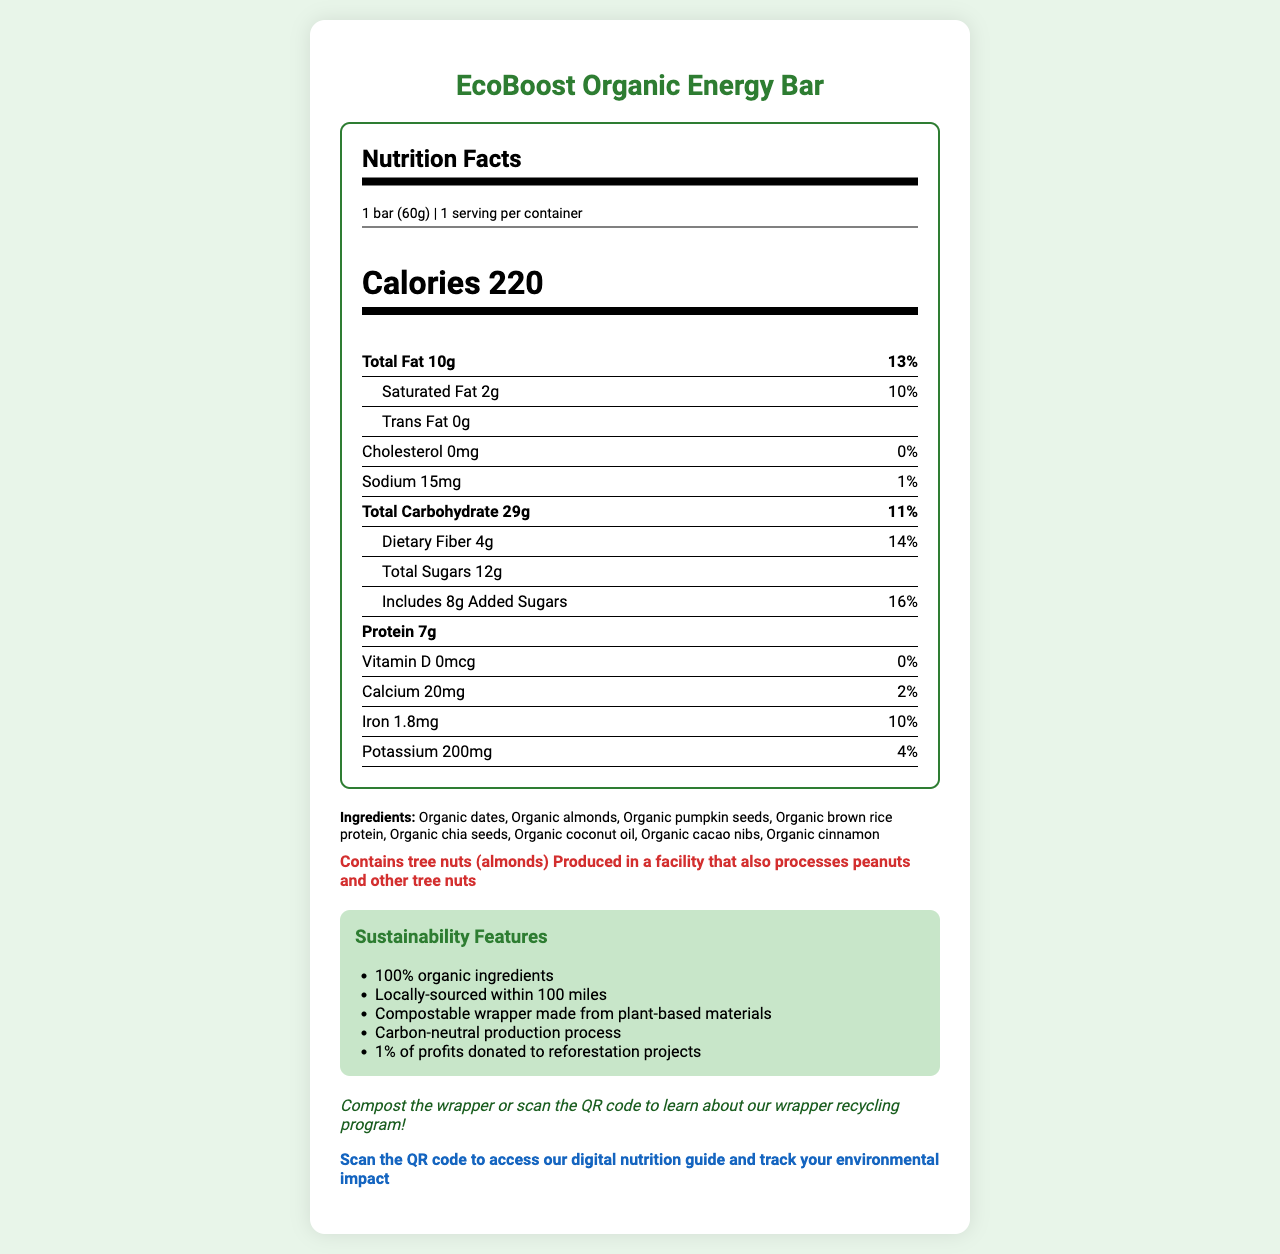what is the serving size? The serving size is clearly listed as "1 bar (60g)" under the serving information section.
Answer: 1 bar (60g) how many calories does one EcoBoost Organic Energy Bar contain? The calorie count is prominently displayed as 220 calories.
Answer: 220 calories which ingredient might pose an allergy risk? The allergen information states "Contains tree nuts (almonds)".
Answer: Tree nuts (almonds) what is the total amount of sugars in this energy bar? The amount of total sugars is listed as "12g" in the nutrition facts.
Answer: 12g what is the daily value percentage for dietary fiber? The daily value percentage for dietary fiber is listed as "14%" next to the amount of dietary fiber.
Answer: 14% what is the primary fatty acid profile in terms of saturated vs. trans fats? A. Saturated fats are higher B. Trans fats are higher C. They are equal D. This bar has no fat The bar contains 2g of saturated fat and 0g of trans fat, meaning saturated fats are higher.
Answer: A. Saturated fats are higher which of the following certifications does this energy bar have? I. USDA Organic II. Non-GMO Project Verified III. Fair Trade Certified IV. Gluten-Free Certified The bar has certifications for USDA Organic, Non-GMO Project Verified, and Fair Trade Certified but not for Gluten-Free Certified.
Answer: I, II, and III is vitamin D present in this energy bar? The nutrition facts state that the vitamin D content is 0mcg, which means it is not present.
Answer: No can the wrapper of this energy bar be composted? The sustainability features and packaging section both mention a compostable wrapper made from plant-based materials.
Answer: Yes what is the main idea of the document? The document is designed to inform consumers about the nutritional, environmental, and sustainability aspects of the EcoBoost Organic Energy Bar, showcasing its health benefits and eco-conscious packaging and production.
Answer: The document provides detailed nutrition information about the EcoBoost Organic Energy Bar, highlighting its nutritional content, ingredients, allergens, sustainability features, and certifications. It emphasizes the bar's organic and locally-sourced ingredients, compostable packaging, and eco-friendly commitments. what is the manufacturer location of this energy bar? The manufacturer information mentions that GreenLife Foods, the producer of the bar, is located in Portland, Oregon.
Answer: Portland, Oregon how much protein is in one serving of the EcoBoost Organic Energy Bar? The nutrition facts list the protein content as "7g" per bar.
Answer: 7g what ingredients are included in this energy bar? The ingredients are listed in the ingredients section.
Answer: Organic dates, Organic almonds, Organic pumpkin seeds, Organic brown rice protein, Organic chia seeds, Organic coconut oil, Organic cacao nibs, Organic cinnamon how much calcium is in the EcoBoost Organic Energy Bar? A. 15mg B. 20mg C. 25mg D. 30mg The nutrition facts state that the calcium content is 20mg per bar.
Answer: B. 20mg is the production process carbon-neutral? One of the sustainability features listed is a "Carbon-neutral production process".
Answer: Yes how long should the EcoBoost Organic Energy Bar be consumed within, for best quality? The storage instructions suggest consuming within 3 months of production for best quality.
Answer: 3 months of production how many grams of added sugars are in the energy bar? The nutrition facts list "Includes 8g Added Sugars" next to the total sugars.
Answer: 8g does this product contain any cholesterol? The nutrition information states that the cholesterol content is 0mg.
Answer: No what is the digital engagement feature mentioned? The digital engagement section prompts users to scan a QR code for more information.
Answer: Scan the QR code to access our digital nutrition guide and track your environmental impact. where can information about wrapper recycling be found? The eco-tip advises to either compost the wrapper or scan the QR code to learn about the wrapper recycling program.
Answer: Scan the QR code on the wrapper. what is the sodium content of the energy bar? The nutrition facts mention that the sodium content is 15mg.
Answer: 15mg does the production facility also process peanuts? The allergen statement mentions that it's produced in a facility that processes peanuts and other tree nuts.
Answer: Yes which of the following is not one of the sustainability features mentioned? A. 100% organic ingredients B. Locally-sourced within 100 miles C. Solar-powered production D. Carbon-neutral production process Solar-powered production is not listed among the sustainability features.
Answer: C. Solar-powered production how is the wrapper labeled by the Biodegradable Products Institute? The packaging section confirms that the wrapper is certified by the Biodegradable Products Institute as compostable.
Answer: Compostable what is the website of the manufacturer of the energy bar? The manufacturer information includes the website www.greenlifefoods.com.
Answer: www.greenlifefoods.com what is the cost of the EcoBoost Organic Energy Bar? The document does not provide any information about the cost of the energy bar.
Answer: Cannot be determined 